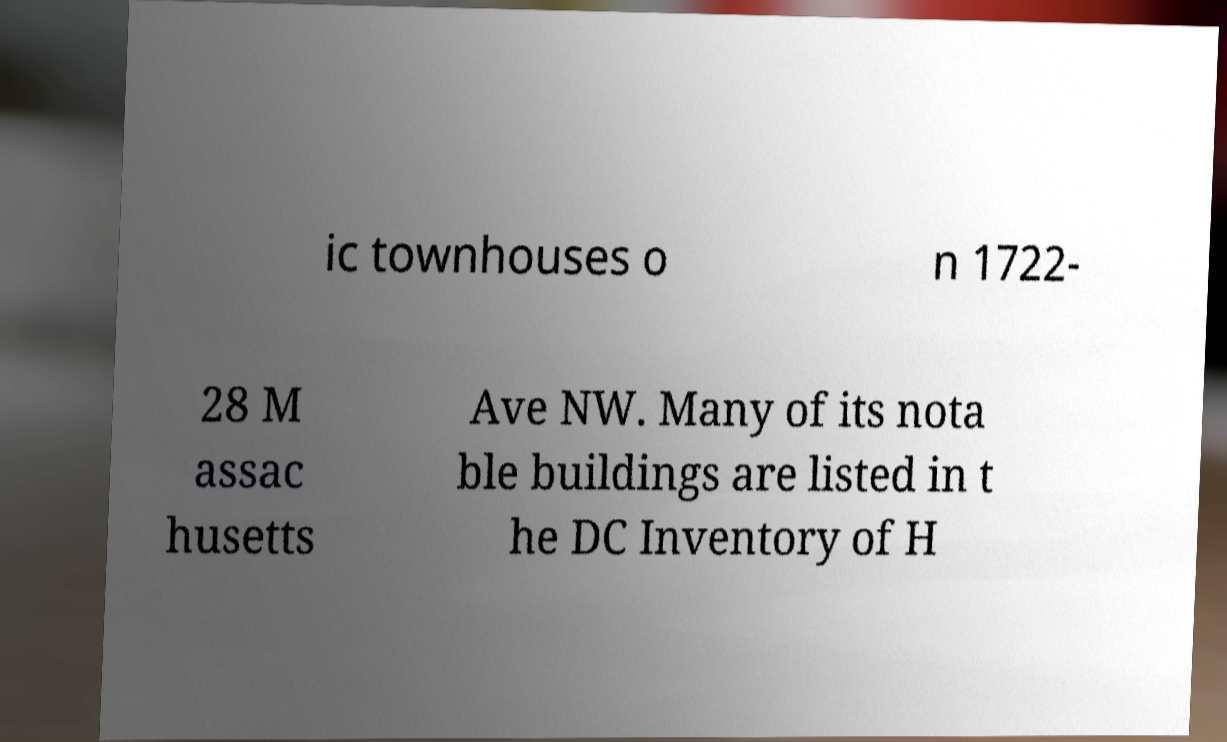Can you read and provide the text displayed in the image?This photo seems to have some interesting text. Can you extract and type it out for me? ic townhouses o n 1722- 28 M assac husetts Ave NW. Many of its nota ble buildings are listed in t he DC Inventory of H 